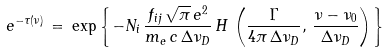Convert formula to latex. <formula><loc_0><loc_0><loc_500><loc_500>e ^ { - \tau ( \nu ) } \, = \, \exp \left \{ - N _ { i } \, \frac { f _ { i j } \, \sqrt { \pi } \, e ^ { 2 } } { m _ { e } \, c \, \Delta \nu _ { D } } \, H \, \left ( { \frac { \Gamma } { 4 \pi \, \Delta \nu _ { D } } } , \, { \frac { \nu - \nu _ { 0 } } { \Delta \nu _ { D } } } \right ) \right \}</formula> 